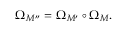<formula> <loc_0><loc_0><loc_500><loc_500>\Omega _ { M ^ { \prime \prime } } = \Omega _ { M ^ { \prime } } \circ \Omega _ { M } .</formula> 